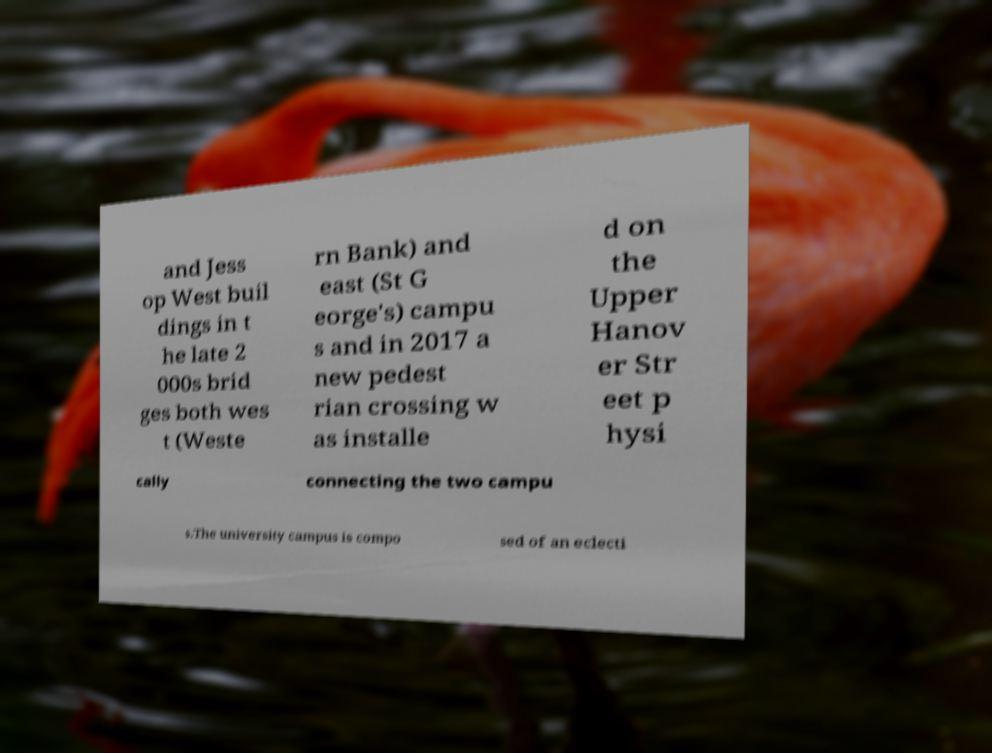There's text embedded in this image that I need extracted. Can you transcribe it verbatim? and Jess op West buil dings in t he late 2 000s brid ges both wes t (Weste rn Bank) and east (St G eorge's) campu s and in 2017 a new pedest rian crossing w as installe d on the Upper Hanov er Str eet p hysi cally connecting the two campu s.The university campus is compo sed of an eclecti 